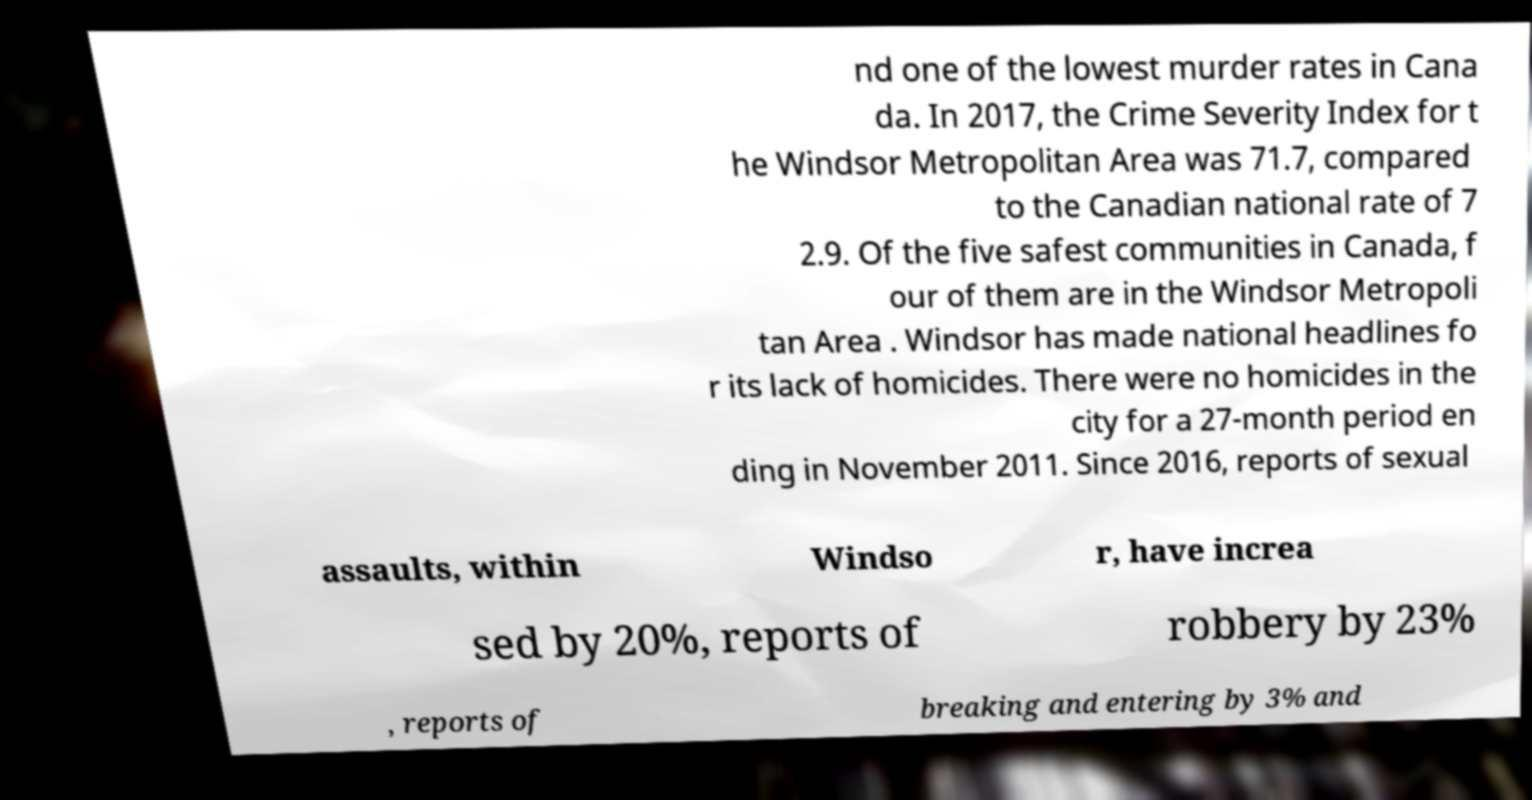What messages or text are displayed in this image? I need them in a readable, typed format. nd one of the lowest murder rates in Cana da. In 2017, the Crime Severity Index for t he Windsor Metropolitan Area was 71.7, compared to the Canadian national rate of 7 2.9. Of the five safest communities in Canada, f our of them are in the Windsor Metropoli tan Area . Windsor has made national headlines fo r its lack of homicides. There were no homicides in the city for a 27-month period en ding in November 2011. Since 2016, reports of sexual assaults, within Windso r, have increa sed by 20%, reports of robbery by 23% , reports of breaking and entering by 3% and 